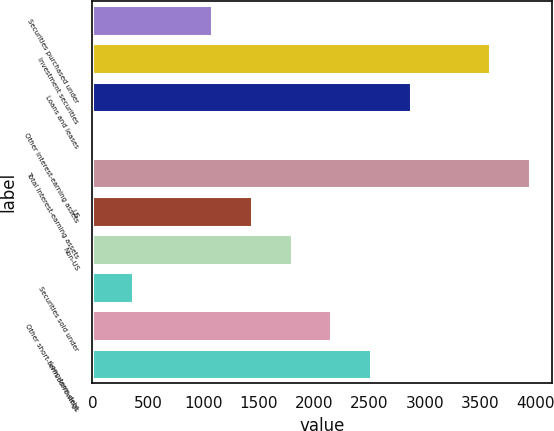Convert chart. <chart><loc_0><loc_0><loc_500><loc_500><bar_chart><fcel>Securities purchased under<fcel>Investment securities<fcel>Loans and leases<fcel>Other interest-earning assets<fcel>Total interest-earning assets<fcel>US<fcel>Non-US<fcel>Securities sold under<fcel>Other short-term borrowings<fcel>Long-term debt<nl><fcel>1079.4<fcel>3591<fcel>2873.4<fcel>3<fcel>3949.8<fcel>1438.2<fcel>1797<fcel>361.8<fcel>2155.8<fcel>2514.6<nl></chart> 